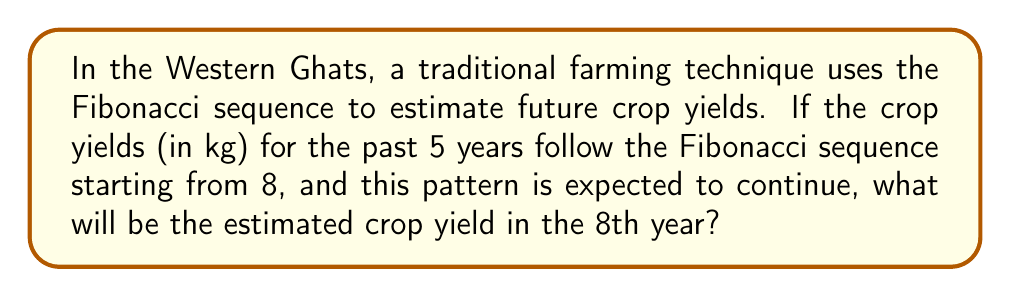Could you help me with this problem? Let's approach this step-by-step:

1) First, recall the Fibonacci sequence: Each number is the sum of the two preceding ones.

2) We're told that the sequence starts with 8, so let's write out the first 5 terms:
   Year 1: 8
   Year 2: 8
   Year 3: 16 (8 + 8)
   Year 4: 24 (8 + 16)
   Year 5: 40 (16 + 24)

3) We need to continue this sequence for three more years:
   Year 6: 64 (24 + 40)
   Year 7: 104 (40 + 64)
   Year 8: 168 (64 + 104)

4) We can verify this using the Fibonacci recurrence relation:
   $$F_n = F_{n-1} + F_{n-2}$$

5) For the 8th term:
   $$F_8 = F_7 + F_6 = 104 + 64 = 168$$

Therefore, the estimated crop yield in the 8th year will be 168 kg.
Answer: 168 kg 